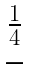Convert formula to latex. <formula><loc_0><loc_0><loc_500><loc_500>\begin{matrix} \frac { 1 } { 4 } \\ - \end{matrix}</formula> 